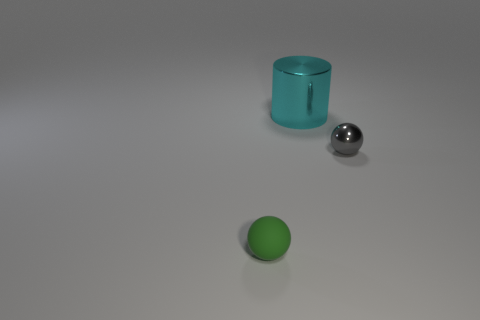How many rubber things are large balls or cyan things? In the image, we have three distinct objects: a cyan-colored cylinder, a large silver sphere, and a smaller green sphere. While the cyan cylinder satisfies the color criterion, none of these objects can be definitively identified as rubber without additional context. However, considering the size, the large silver sphere can be considered a large ball, and the cyan cylinder meets the color criteria. Therefore, there are two objects in the image that meet the criteria of being either large balls or cyan things. 